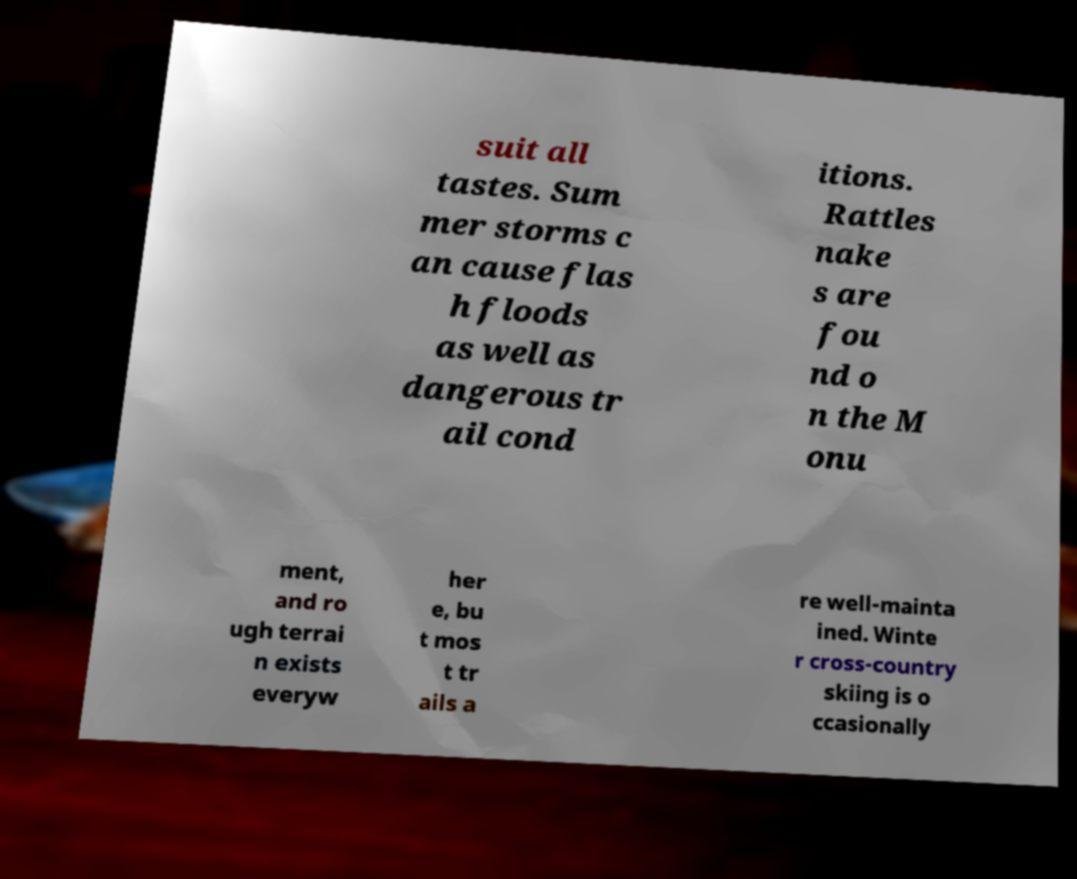There's text embedded in this image that I need extracted. Can you transcribe it verbatim? suit all tastes. Sum mer storms c an cause flas h floods as well as dangerous tr ail cond itions. Rattles nake s are fou nd o n the M onu ment, and ro ugh terrai n exists everyw her e, bu t mos t tr ails a re well-mainta ined. Winte r cross-country skiing is o ccasionally 